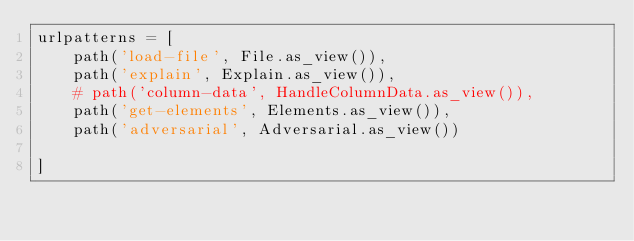<code> <loc_0><loc_0><loc_500><loc_500><_Python_>urlpatterns = [
    path('load-file', File.as_view()),
    path('explain', Explain.as_view()),
    # path('column-data', HandleColumnData.as_view()),
    path('get-elements', Elements.as_view()),
    path('adversarial', Adversarial.as_view())

]
</code> 